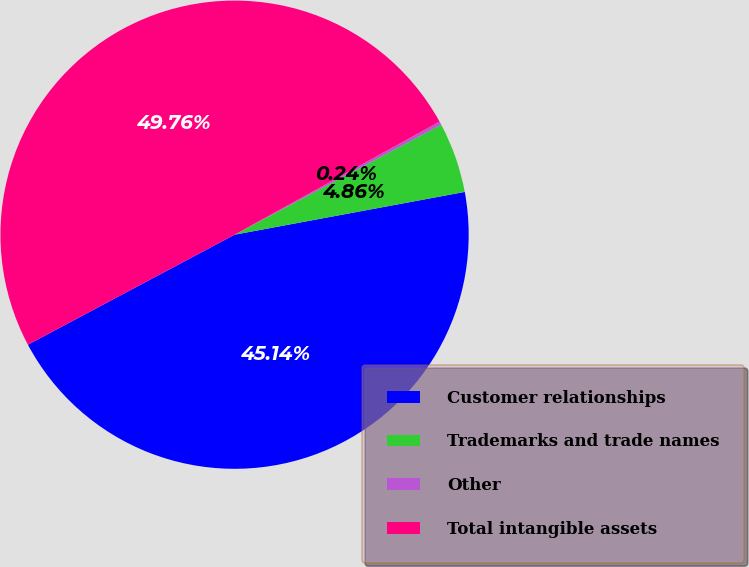Convert chart. <chart><loc_0><loc_0><loc_500><loc_500><pie_chart><fcel>Customer relationships<fcel>Trademarks and trade names<fcel>Other<fcel>Total intangible assets<nl><fcel>45.14%<fcel>4.86%<fcel>0.24%<fcel>49.76%<nl></chart> 